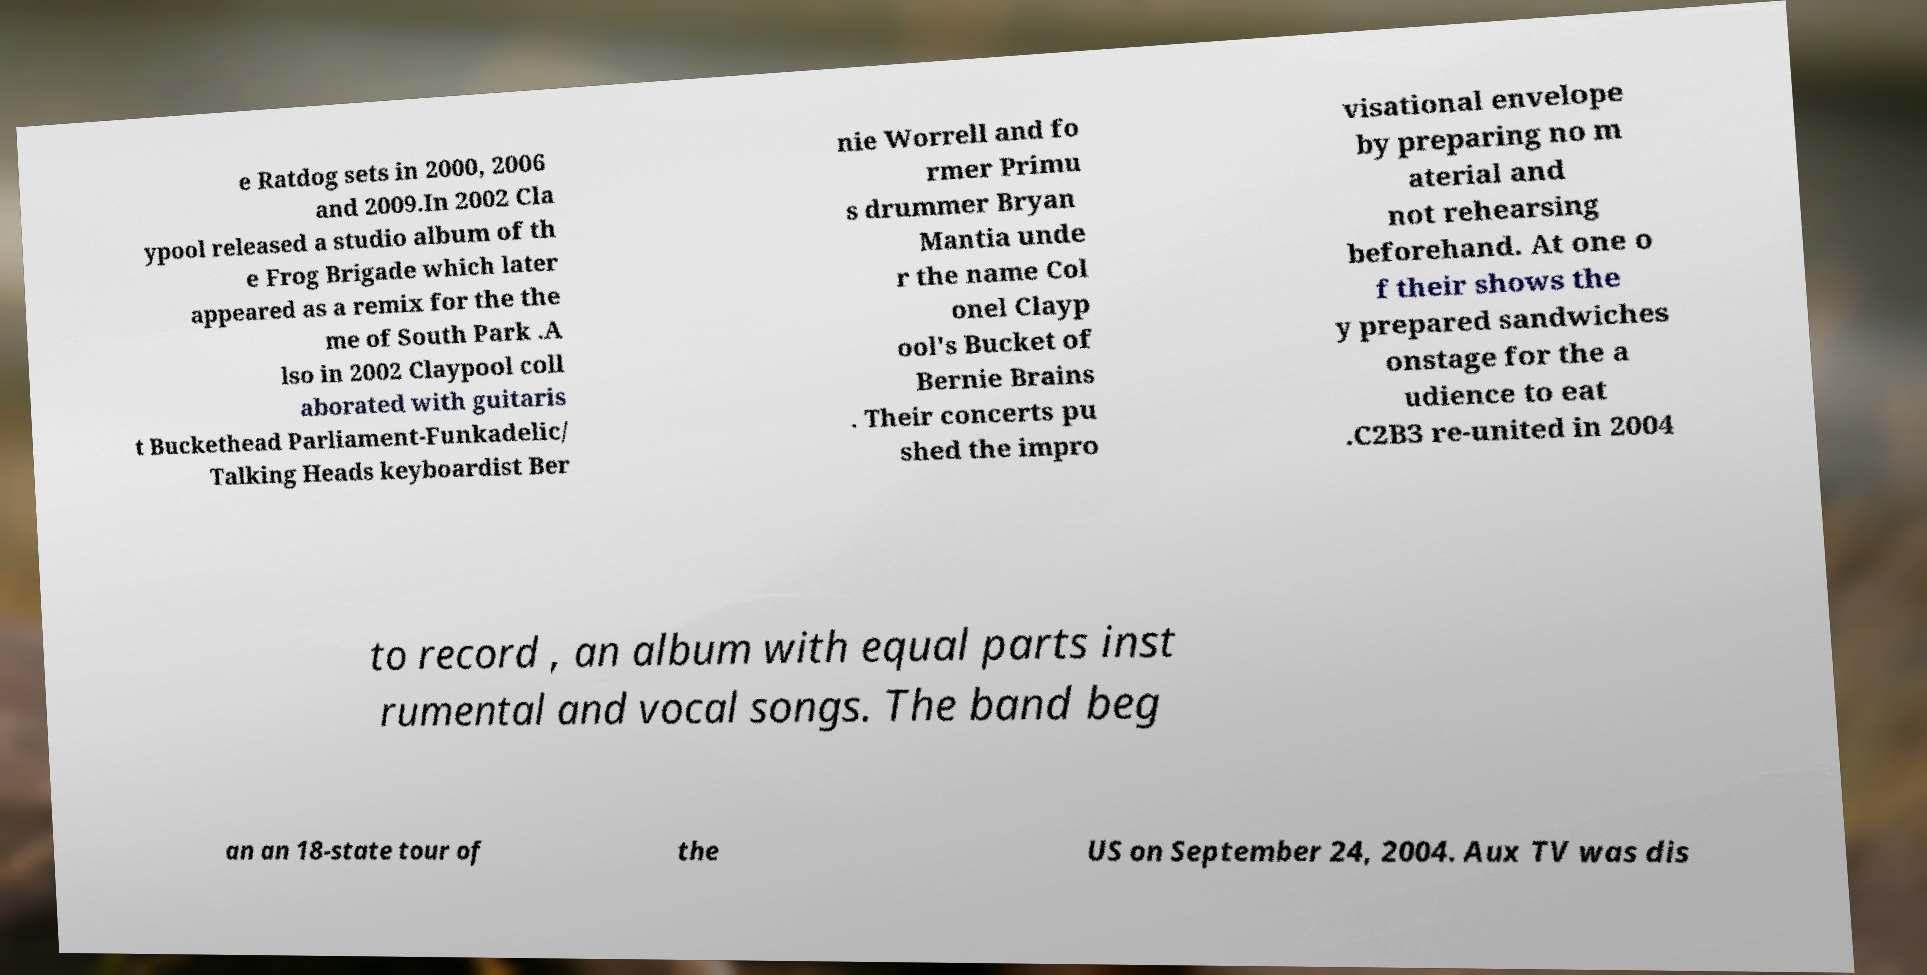I need the written content from this picture converted into text. Can you do that? e Ratdog sets in 2000, 2006 and 2009.In 2002 Cla ypool released a studio album of th e Frog Brigade which later appeared as a remix for the the me of South Park .A lso in 2002 Claypool coll aborated with guitaris t Buckethead Parliament-Funkadelic/ Talking Heads keyboardist Ber nie Worrell and fo rmer Primu s drummer Bryan Mantia unde r the name Col onel Clayp ool's Bucket of Bernie Brains . Their concerts pu shed the impro visational envelope by preparing no m aterial and not rehearsing beforehand. At one o f their shows the y prepared sandwiches onstage for the a udience to eat .C2B3 re-united in 2004 to record , an album with equal parts inst rumental and vocal songs. The band beg an an 18-state tour of the US on September 24, 2004. Aux TV was dis 